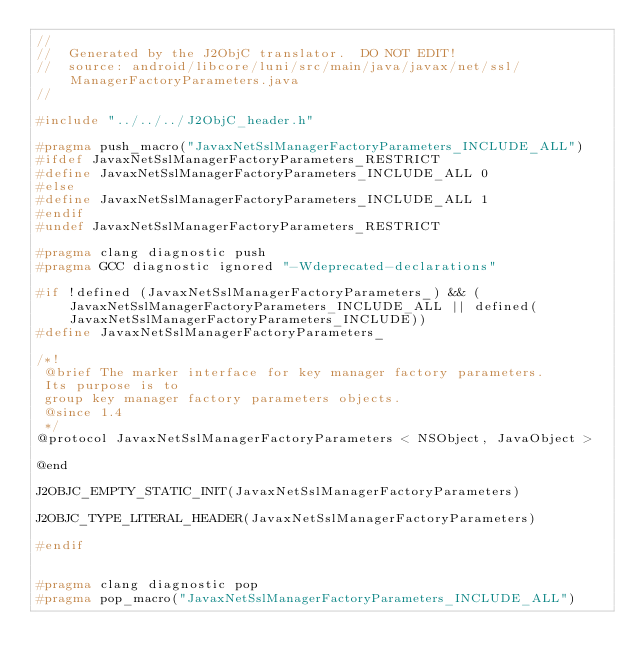<code> <loc_0><loc_0><loc_500><loc_500><_C_>//
//  Generated by the J2ObjC translator.  DO NOT EDIT!
//  source: android/libcore/luni/src/main/java/javax/net/ssl/ManagerFactoryParameters.java
//

#include "../../../J2ObjC_header.h"

#pragma push_macro("JavaxNetSslManagerFactoryParameters_INCLUDE_ALL")
#ifdef JavaxNetSslManagerFactoryParameters_RESTRICT
#define JavaxNetSslManagerFactoryParameters_INCLUDE_ALL 0
#else
#define JavaxNetSslManagerFactoryParameters_INCLUDE_ALL 1
#endif
#undef JavaxNetSslManagerFactoryParameters_RESTRICT

#pragma clang diagnostic push
#pragma GCC diagnostic ignored "-Wdeprecated-declarations"

#if !defined (JavaxNetSslManagerFactoryParameters_) && (JavaxNetSslManagerFactoryParameters_INCLUDE_ALL || defined(JavaxNetSslManagerFactoryParameters_INCLUDE))
#define JavaxNetSslManagerFactoryParameters_

/*!
 @brief The marker interface for key manager factory parameters.
 Its purpose is to
 group key manager factory parameters objects.
 @since 1.4
 */
@protocol JavaxNetSslManagerFactoryParameters < NSObject, JavaObject >

@end

J2OBJC_EMPTY_STATIC_INIT(JavaxNetSslManagerFactoryParameters)

J2OBJC_TYPE_LITERAL_HEADER(JavaxNetSslManagerFactoryParameters)

#endif


#pragma clang diagnostic pop
#pragma pop_macro("JavaxNetSslManagerFactoryParameters_INCLUDE_ALL")
</code> 